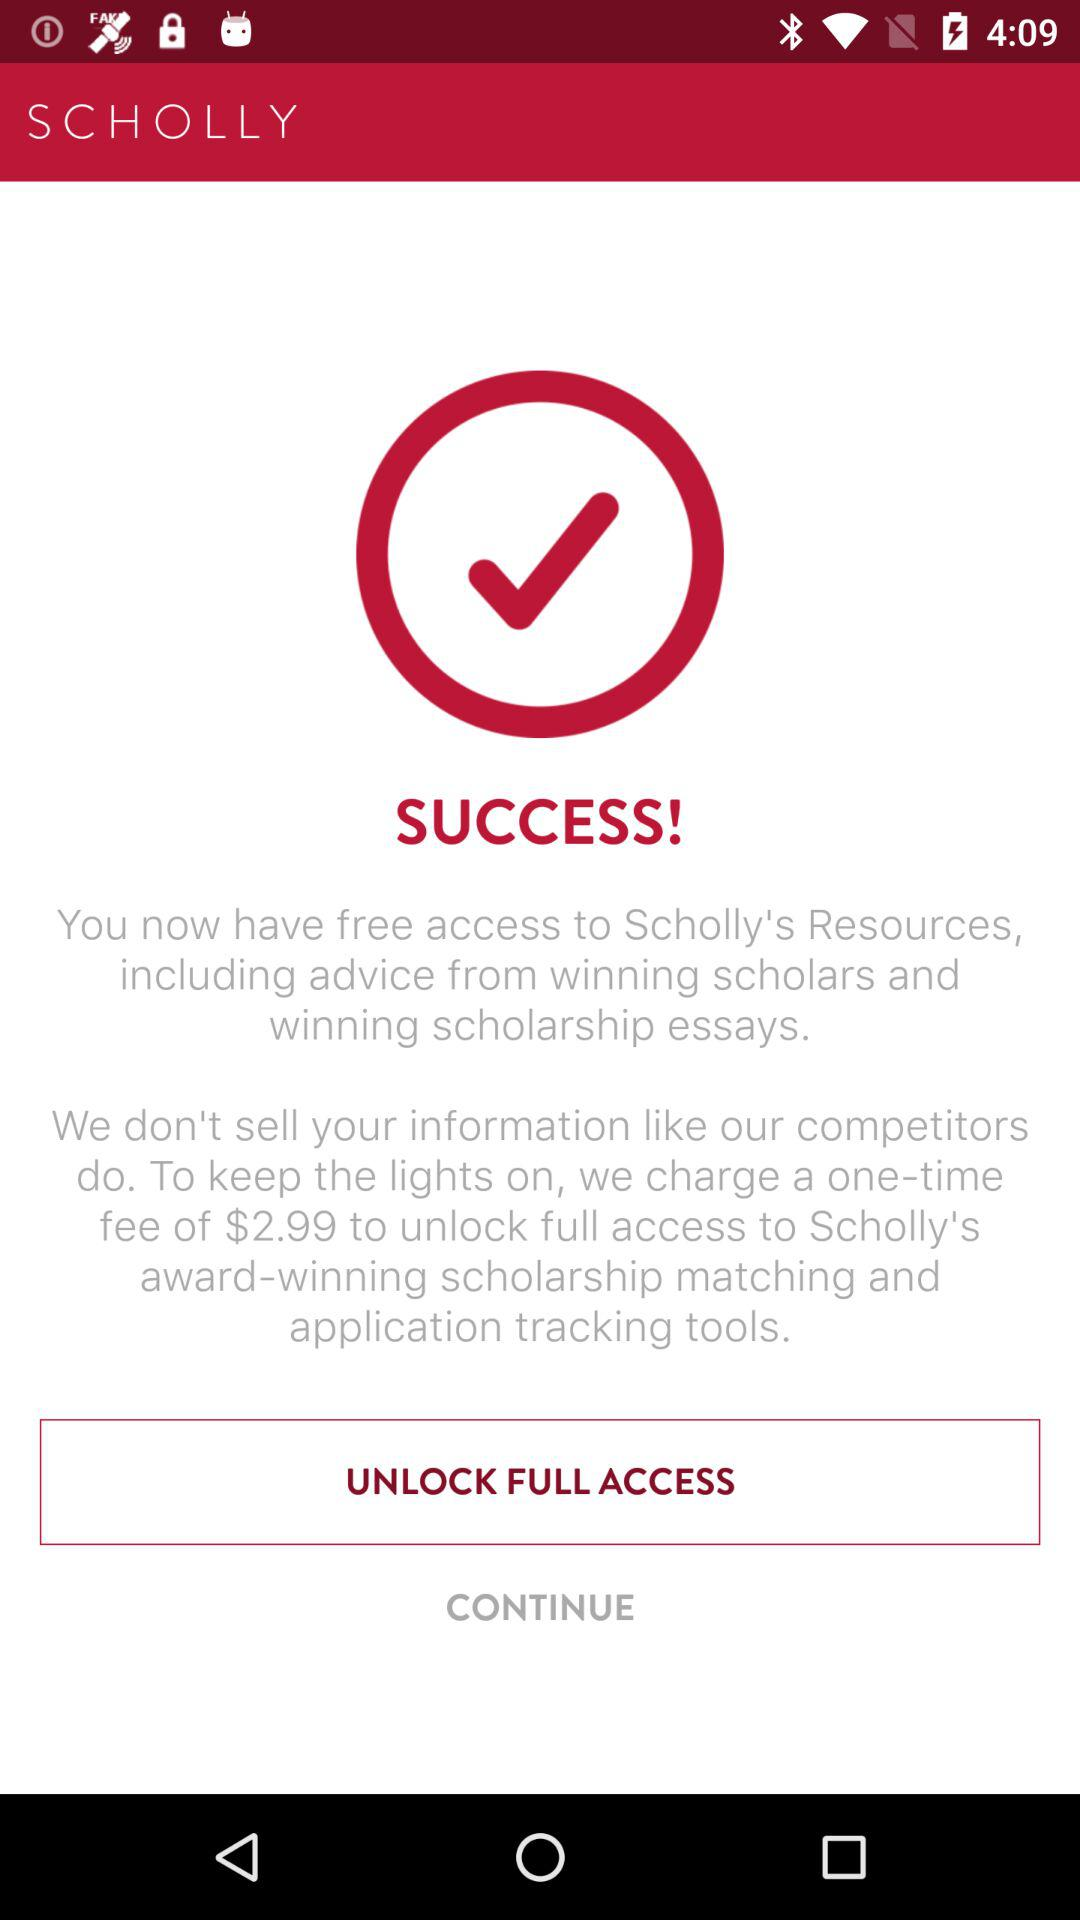How much more does it cost to unlock full access than to have free access to resources?
Answer the question using a single word or phrase. $2.99 